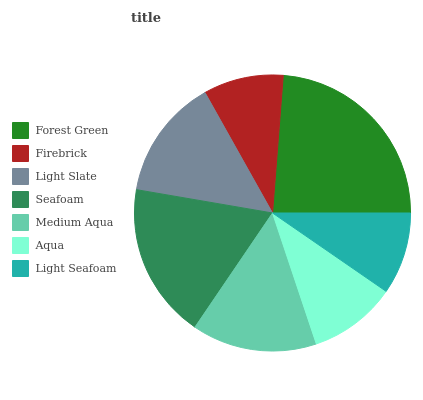Is Firebrick the minimum?
Answer yes or no. Yes. Is Forest Green the maximum?
Answer yes or no. Yes. Is Light Slate the minimum?
Answer yes or no. No. Is Light Slate the maximum?
Answer yes or no. No. Is Light Slate greater than Firebrick?
Answer yes or no. Yes. Is Firebrick less than Light Slate?
Answer yes or no. Yes. Is Firebrick greater than Light Slate?
Answer yes or no. No. Is Light Slate less than Firebrick?
Answer yes or no. No. Is Light Slate the high median?
Answer yes or no. Yes. Is Light Slate the low median?
Answer yes or no. Yes. Is Aqua the high median?
Answer yes or no. No. Is Medium Aqua the low median?
Answer yes or no. No. 